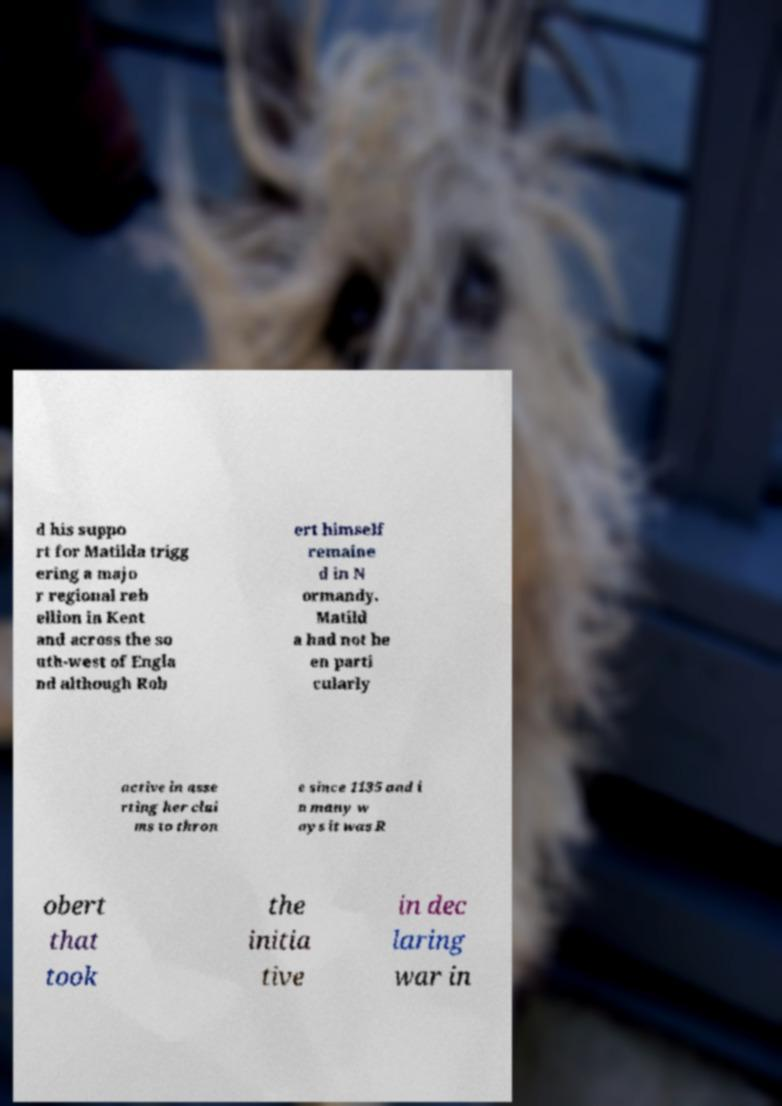Could you extract and type out the text from this image? d his suppo rt for Matilda trigg ering a majo r regional reb ellion in Kent and across the so uth-west of Engla nd although Rob ert himself remaine d in N ormandy. Matild a had not be en parti cularly active in asse rting her clai ms to thron e since 1135 and i n many w ays it was R obert that took the initia tive in dec laring war in 